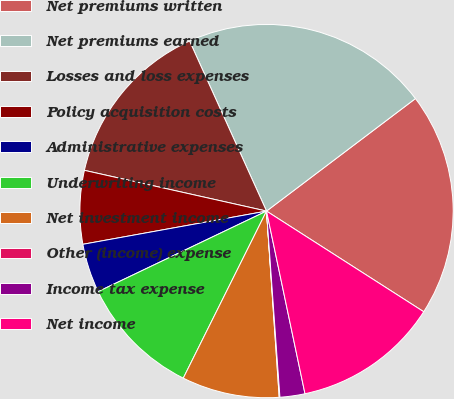Convert chart. <chart><loc_0><loc_0><loc_500><loc_500><pie_chart><fcel>Net premiums written<fcel>Net premiums earned<fcel>Losses and loss expenses<fcel>Policy acquisition costs<fcel>Administrative expenses<fcel>Underwriting income<fcel>Net investment income<fcel>Other (income) expense<fcel>Income tax expense<fcel>Net income<nl><fcel>19.36%<fcel>21.46%<fcel>14.73%<fcel>6.35%<fcel>4.25%<fcel>10.54%<fcel>8.44%<fcel>0.06%<fcel>2.16%<fcel>12.63%<nl></chart> 